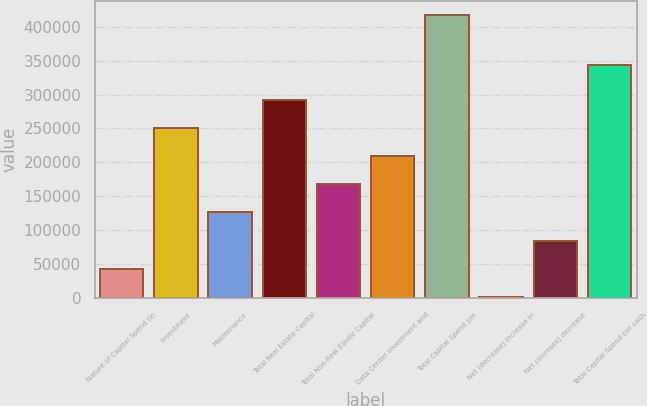Convert chart. <chart><loc_0><loc_0><loc_500><loc_500><bar_chart><fcel>Nature of Capital Spend (in<fcel>Investment<fcel>Maintenance<fcel>Total Real Estate Capital<fcel>Total Non-Real Estate Capital<fcel>Data Center Investment and<fcel>Total Capital Spend (on<fcel>Net (decrease) increase in<fcel>Net (increase) decrease<fcel>Total Capital Spend (on cash<nl><fcel>43134.1<fcel>250660<fcel>126144<fcel>292165<fcel>167649<fcel>209154<fcel>416680<fcel>1629<fcel>84639.2<fcel>343131<nl></chart> 